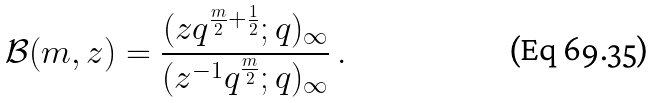Convert formula to latex. <formula><loc_0><loc_0><loc_500><loc_500>\mathcal { B } ( m , z ) = \frac { ( z q ^ { \frac { m } { 2 } + \frac { 1 } { 2 } } ; q ) _ { \infty } } { ( z ^ { - 1 } q ^ { \frac { m } { 2 } } ; q ) _ { \infty } } \, .</formula> 